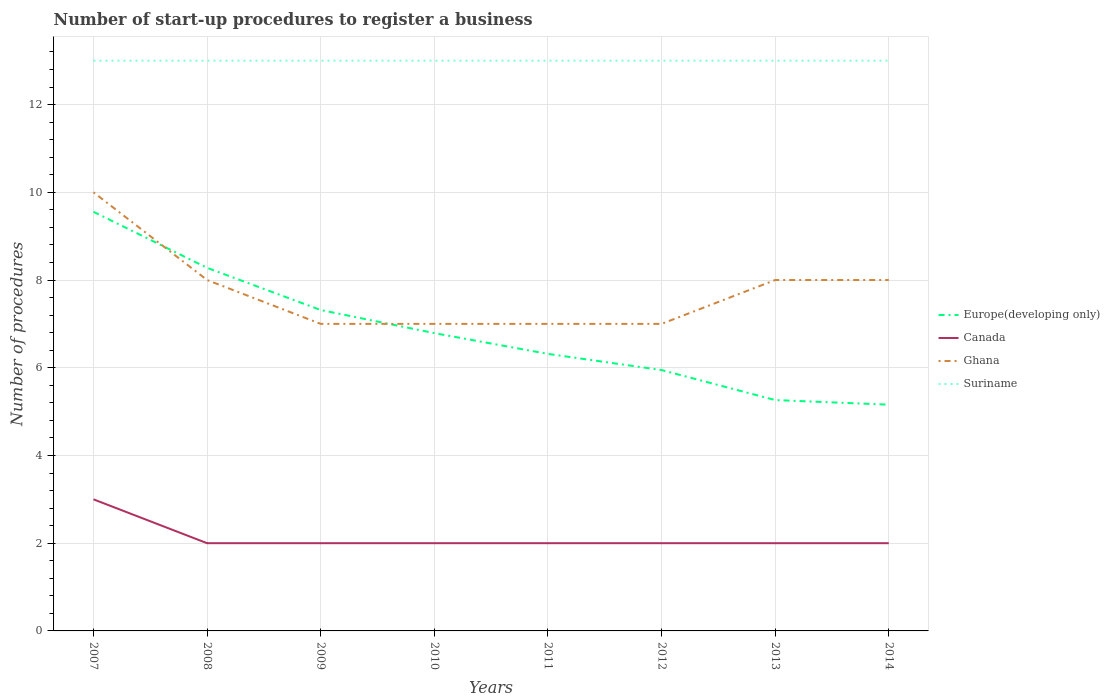How many different coloured lines are there?
Offer a terse response. 4. Is the number of lines equal to the number of legend labels?
Keep it short and to the point. Yes. Across all years, what is the maximum number of procedures required to register a business in Europe(developing only)?
Keep it short and to the point. 5.16. What is the difference between the highest and the second highest number of procedures required to register a business in Ghana?
Provide a succinct answer. 3. What is the difference between the highest and the lowest number of procedures required to register a business in Ghana?
Your response must be concise. 4. How many years are there in the graph?
Keep it short and to the point. 8. Are the values on the major ticks of Y-axis written in scientific E-notation?
Ensure brevity in your answer.  No. Does the graph contain any zero values?
Provide a short and direct response. No. Does the graph contain grids?
Offer a very short reply. Yes. Where does the legend appear in the graph?
Your response must be concise. Center right. How many legend labels are there?
Give a very brief answer. 4. How are the legend labels stacked?
Your answer should be very brief. Vertical. What is the title of the graph?
Your answer should be compact. Number of start-up procedures to register a business. Does "Kiribati" appear as one of the legend labels in the graph?
Make the answer very short. No. What is the label or title of the Y-axis?
Offer a very short reply. Number of procedures. What is the Number of procedures in Europe(developing only) in 2007?
Provide a short and direct response. 9.56. What is the Number of procedures of Canada in 2007?
Your response must be concise. 3. What is the Number of procedures of Suriname in 2007?
Provide a succinct answer. 13. What is the Number of procedures in Europe(developing only) in 2008?
Offer a terse response. 8.28. What is the Number of procedures in Canada in 2008?
Keep it short and to the point. 2. What is the Number of procedures in Suriname in 2008?
Keep it short and to the point. 13. What is the Number of procedures in Europe(developing only) in 2009?
Give a very brief answer. 7.32. What is the Number of procedures in Ghana in 2009?
Your answer should be very brief. 7. What is the Number of procedures in Suriname in 2009?
Give a very brief answer. 13. What is the Number of procedures of Europe(developing only) in 2010?
Your answer should be very brief. 6.79. What is the Number of procedures in Europe(developing only) in 2011?
Your answer should be compact. 6.32. What is the Number of procedures in Canada in 2011?
Your answer should be compact. 2. What is the Number of procedures of Europe(developing only) in 2012?
Your answer should be compact. 5.95. What is the Number of procedures of Canada in 2012?
Offer a very short reply. 2. What is the Number of procedures in Europe(developing only) in 2013?
Provide a short and direct response. 5.26. What is the Number of procedures of Suriname in 2013?
Your answer should be compact. 13. What is the Number of procedures of Europe(developing only) in 2014?
Ensure brevity in your answer.  5.16. What is the Number of procedures in Ghana in 2014?
Make the answer very short. 8. Across all years, what is the maximum Number of procedures in Europe(developing only)?
Your answer should be compact. 9.56. Across all years, what is the maximum Number of procedures in Canada?
Your answer should be compact. 3. Across all years, what is the maximum Number of procedures of Suriname?
Provide a short and direct response. 13. Across all years, what is the minimum Number of procedures of Europe(developing only)?
Offer a terse response. 5.16. Across all years, what is the minimum Number of procedures in Canada?
Keep it short and to the point. 2. Across all years, what is the minimum Number of procedures in Ghana?
Keep it short and to the point. 7. What is the total Number of procedures in Europe(developing only) in the graph?
Offer a terse response. 54.62. What is the total Number of procedures of Suriname in the graph?
Offer a terse response. 104. What is the difference between the Number of procedures of Europe(developing only) in 2007 and that in 2008?
Your answer should be very brief. 1.28. What is the difference between the Number of procedures of Canada in 2007 and that in 2008?
Ensure brevity in your answer.  1. What is the difference between the Number of procedures of Suriname in 2007 and that in 2008?
Offer a very short reply. 0. What is the difference between the Number of procedures in Europe(developing only) in 2007 and that in 2009?
Offer a terse response. 2.24. What is the difference between the Number of procedures of Canada in 2007 and that in 2009?
Your answer should be compact. 1. What is the difference between the Number of procedures in Ghana in 2007 and that in 2009?
Ensure brevity in your answer.  3. What is the difference between the Number of procedures in Suriname in 2007 and that in 2009?
Provide a succinct answer. 0. What is the difference between the Number of procedures in Europe(developing only) in 2007 and that in 2010?
Provide a succinct answer. 2.77. What is the difference between the Number of procedures in Suriname in 2007 and that in 2010?
Your answer should be compact. 0. What is the difference between the Number of procedures of Europe(developing only) in 2007 and that in 2011?
Offer a terse response. 3.24. What is the difference between the Number of procedures in Canada in 2007 and that in 2011?
Make the answer very short. 1. What is the difference between the Number of procedures in Ghana in 2007 and that in 2011?
Offer a terse response. 3. What is the difference between the Number of procedures in Europe(developing only) in 2007 and that in 2012?
Provide a succinct answer. 3.61. What is the difference between the Number of procedures of Canada in 2007 and that in 2012?
Provide a short and direct response. 1. What is the difference between the Number of procedures in Ghana in 2007 and that in 2012?
Your answer should be compact. 3. What is the difference between the Number of procedures in Europe(developing only) in 2007 and that in 2013?
Your response must be concise. 4.29. What is the difference between the Number of procedures in Europe(developing only) in 2007 and that in 2014?
Your answer should be compact. 4.4. What is the difference between the Number of procedures in Suriname in 2007 and that in 2014?
Offer a terse response. 0. What is the difference between the Number of procedures of Suriname in 2008 and that in 2009?
Ensure brevity in your answer.  0. What is the difference between the Number of procedures of Europe(developing only) in 2008 and that in 2010?
Provide a succinct answer. 1.49. What is the difference between the Number of procedures in Canada in 2008 and that in 2010?
Your answer should be compact. 0. What is the difference between the Number of procedures in Ghana in 2008 and that in 2010?
Make the answer very short. 1. What is the difference between the Number of procedures of Europe(developing only) in 2008 and that in 2011?
Your answer should be compact. 1.96. What is the difference between the Number of procedures of Ghana in 2008 and that in 2011?
Offer a terse response. 1. What is the difference between the Number of procedures in Europe(developing only) in 2008 and that in 2012?
Your response must be concise. 2.33. What is the difference between the Number of procedures in Ghana in 2008 and that in 2012?
Give a very brief answer. 1. What is the difference between the Number of procedures of Suriname in 2008 and that in 2012?
Give a very brief answer. 0. What is the difference between the Number of procedures of Europe(developing only) in 2008 and that in 2013?
Offer a very short reply. 3.01. What is the difference between the Number of procedures of Ghana in 2008 and that in 2013?
Provide a succinct answer. 0. What is the difference between the Number of procedures in Suriname in 2008 and that in 2013?
Keep it short and to the point. 0. What is the difference between the Number of procedures in Europe(developing only) in 2008 and that in 2014?
Give a very brief answer. 3.12. What is the difference between the Number of procedures in Ghana in 2008 and that in 2014?
Your answer should be very brief. 0. What is the difference between the Number of procedures in Europe(developing only) in 2009 and that in 2010?
Your response must be concise. 0.53. What is the difference between the Number of procedures in Canada in 2009 and that in 2010?
Your response must be concise. 0. What is the difference between the Number of procedures of Ghana in 2009 and that in 2010?
Provide a succinct answer. 0. What is the difference between the Number of procedures in Suriname in 2009 and that in 2010?
Your answer should be compact. 0. What is the difference between the Number of procedures in Ghana in 2009 and that in 2011?
Your answer should be very brief. 0. What is the difference between the Number of procedures of Suriname in 2009 and that in 2011?
Your answer should be compact. 0. What is the difference between the Number of procedures of Europe(developing only) in 2009 and that in 2012?
Your answer should be compact. 1.37. What is the difference between the Number of procedures in Ghana in 2009 and that in 2012?
Make the answer very short. 0. What is the difference between the Number of procedures in Suriname in 2009 and that in 2012?
Offer a very short reply. 0. What is the difference between the Number of procedures of Europe(developing only) in 2009 and that in 2013?
Your answer should be very brief. 2.05. What is the difference between the Number of procedures of Ghana in 2009 and that in 2013?
Provide a succinct answer. -1. What is the difference between the Number of procedures of Europe(developing only) in 2009 and that in 2014?
Ensure brevity in your answer.  2.16. What is the difference between the Number of procedures in Canada in 2009 and that in 2014?
Provide a short and direct response. 0. What is the difference between the Number of procedures of Ghana in 2009 and that in 2014?
Ensure brevity in your answer.  -1. What is the difference between the Number of procedures of Suriname in 2009 and that in 2014?
Offer a terse response. 0. What is the difference between the Number of procedures in Europe(developing only) in 2010 and that in 2011?
Provide a succinct answer. 0.47. What is the difference between the Number of procedures in Canada in 2010 and that in 2011?
Your response must be concise. 0. What is the difference between the Number of procedures of Ghana in 2010 and that in 2011?
Offer a terse response. 0. What is the difference between the Number of procedures of Europe(developing only) in 2010 and that in 2012?
Keep it short and to the point. 0.84. What is the difference between the Number of procedures in Suriname in 2010 and that in 2012?
Keep it short and to the point. 0. What is the difference between the Number of procedures of Europe(developing only) in 2010 and that in 2013?
Provide a succinct answer. 1.53. What is the difference between the Number of procedures in Canada in 2010 and that in 2013?
Your answer should be compact. 0. What is the difference between the Number of procedures of Suriname in 2010 and that in 2013?
Give a very brief answer. 0. What is the difference between the Number of procedures of Europe(developing only) in 2010 and that in 2014?
Your answer should be compact. 1.63. What is the difference between the Number of procedures of Suriname in 2010 and that in 2014?
Offer a terse response. 0. What is the difference between the Number of procedures of Europe(developing only) in 2011 and that in 2012?
Provide a short and direct response. 0.37. What is the difference between the Number of procedures of Suriname in 2011 and that in 2012?
Make the answer very short. 0. What is the difference between the Number of procedures in Europe(developing only) in 2011 and that in 2013?
Provide a succinct answer. 1.05. What is the difference between the Number of procedures in Ghana in 2011 and that in 2013?
Give a very brief answer. -1. What is the difference between the Number of procedures in Europe(developing only) in 2011 and that in 2014?
Ensure brevity in your answer.  1.16. What is the difference between the Number of procedures of Ghana in 2011 and that in 2014?
Provide a succinct answer. -1. What is the difference between the Number of procedures in Suriname in 2011 and that in 2014?
Provide a short and direct response. 0. What is the difference between the Number of procedures of Europe(developing only) in 2012 and that in 2013?
Your answer should be compact. 0.68. What is the difference between the Number of procedures of Ghana in 2012 and that in 2013?
Provide a succinct answer. -1. What is the difference between the Number of procedures in Suriname in 2012 and that in 2013?
Provide a succinct answer. 0. What is the difference between the Number of procedures in Europe(developing only) in 2012 and that in 2014?
Your response must be concise. 0.79. What is the difference between the Number of procedures in Canada in 2012 and that in 2014?
Keep it short and to the point. 0. What is the difference between the Number of procedures of Ghana in 2012 and that in 2014?
Offer a terse response. -1. What is the difference between the Number of procedures of Europe(developing only) in 2013 and that in 2014?
Give a very brief answer. 0.11. What is the difference between the Number of procedures in Canada in 2013 and that in 2014?
Give a very brief answer. 0. What is the difference between the Number of procedures in Ghana in 2013 and that in 2014?
Keep it short and to the point. 0. What is the difference between the Number of procedures in Europe(developing only) in 2007 and the Number of procedures in Canada in 2008?
Ensure brevity in your answer.  7.56. What is the difference between the Number of procedures in Europe(developing only) in 2007 and the Number of procedures in Ghana in 2008?
Keep it short and to the point. 1.56. What is the difference between the Number of procedures of Europe(developing only) in 2007 and the Number of procedures of Suriname in 2008?
Your answer should be very brief. -3.44. What is the difference between the Number of procedures of Canada in 2007 and the Number of procedures of Ghana in 2008?
Offer a terse response. -5. What is the difference between the Number of procedures of Europe(developing only) in 2007 and the Number of procedures of Canada in 2009?
Offer a very short reply. 7.56. What is the difference between the Number of procedures in Europe(developing only) in 2007 and the Number of procedures in Ghana in 2009?
Make the answer very short. 2.56. What is the difference between the Number of procedures in Europe(developing only) in 2007 and the Number of procedures in Suriname in 2009?
Provide a short and direct response. -3.44. What is the difference between the Number of procedures in Canada in 2007 and the Number of procedures in Ghana in 2009?
Ensure brevity in your answer.  -4. What is the difference between the Number of procedures of Ghana in 2007 and the Number of procedures of Suriname in 2009?
Offer a terse response. -3. What is the difference between the Number of procedures of Europe(developing only) in 2007 and the Number of procedures of Canada in 2010?
Offer a terse response. 7.56. What is the difference between the Number of procedures in Europe(developing only) in 2007 and the Number of procedures in Ghana in 2010?
Offer a very short reply. 2.56. What is the difference between the Number of procedures in Europe(developing only) in 2007 and the Number of procedures in Suriname in 2010?
Offer a terse response. -3.44. What is the difference between the Number of procedures of Canada in 2007 and the Number of procedures of Ghana in 2010?
Offer a very short reply. -4. What is the difference between the Number of procedures of Ghana in 2007 and the Number of procedures of Suriname in 2010?
Make the answer very short. -3. What is the difference between the Number of procedures in Europe(developing only) in 2007 and the Number of procedures in Canada in 2011?
Ensure brevity in your answer.  7.56. What is the difference between the Number of procedures in Europe(developing only) in 2007 and the Number of procedures in Ghana in 2011?
Your response must be concise. 2.56. What is the difference between the Number of procedures in Europe(developing only) in 2007 and the Number of procedures in Suriname in 2011?
Give a very brief answer. -3.44. What is the difference between the Number of procedures in Europe(developing only) in 2007 and the Number of procedures in Canada in 2012?
Your answer should be very brief. 7.56. What is the difference between the Number of procedures in Europe(developing only) in 2007 and the Number of procedures in Ghana in 2012?
Your answer should be compact. 2.56. What is the difference between the Number of procedures in Europe(developing only) in 2007 and the Number of procedures in Suriname in 2012?
Your response must be concise. -3.44. What is the difference between the Number of procedures of Canada in 2007 and the Number of procedures of Suriname in 2012?
Offer a very short reply. -10. What is the difference between the Number of procedures in Ghana in 2007 and the Number of procedures in Suriname in 2012?
Your answer should be compact. -3. What is the difference between the Number of procedures in Europe(developing only) in 2007 and the Number of procedures in Canada in 2013?
Your response must be concise. 7.56. What is the difference between the Number of procedures in Europe(developing only) in 2007 and the Number of procedures in Ghana in 2013?
Provide a short and direct response. 1.56. What is the difference between the Number of procedures of Europe(developing only) in 2007 and the Number of procedures of Suriname in 2013?
Make the answer very short. -3.44. What is the difference between the Number of procedures of Ghana in 2007 and the Number of procedures of Suriname in 2013?
Offer a terse response. -3. What is the difference between the Number of procedures in Europe(developing only) in 2007 and the Number of procedures in Canada in 2014?
Keep it short and to the point. 7.56. What is the difference between the Number of procedures of Europe(developing only) in 2007 and the Number of procedures of Ghana in 2014?
Offer a very short reply. 1.56. What is the difference between the Number of procedures in Europe(developing only) in 2007 and the Number of procedures in Suriname in 2014?
Provide a succinct answer. -3.44. What is the difference between the Number of procedures of Canada in 2007 and the Number of procedures of Suriname in 2014?
Provide a succinct answer. -10. What is the difference between the Number of procedures in Ghana in 2007 and the Number of procedures in Suriname in 2014?
Your answer should be compact. -3. What is the difference between the Number of procedures of Europe(developing only) in 2008 and the Number of procedures of Canada in 2009?
Provide a succinct answer. 6.28. What is the difference between the Number of procedures in Europe(developing only) in 2008 and the Number of procedures in Ghana in 2009?
Keep it short and to the point. 1.28. What is the difference between the Number of procedures of Europe(developing only) in 2008 and the Number of procedures of Suriname in 2009?
Offer a terse response. -4.72. What is the difference between the Number of procedures of Ghana in 2008 and the Number of procedures of Suriname in 2009?
Keep it short and to the point. -5. What is the difference between the Number of procedures in Europe(developing only) in 2008 and the Number of procedures in Canada in 2010?
Provide a succinct answer. 6.28. What is the difference between the Number of procedures of Europe(developing only) in 2008 and the Number of procedures of Ghana in 2010?
Provide a short and direct response. 1.28. What is the difference between the Number of procedures in Europe(developing only) in 2008 and the Number of procedures in Suriname in 2010?
Ensure brevity in your answer.  -4.72. What is the difference between the Number of procedures in Europe(developing only) in 2008 and the Number of procedures in Canada in 2011?
Your response must be concise. 6.28. What is the difference between the Number of procedures of Europe(developing only) in 2008 and the Number of procedures of Ghana in 2011?
Give a very brief answer. 1.28. What is the difference between the Number of procedures of Europe(developing only) in 2008 and the Number of procedures of Suriname in 2011?
Keep it short and to the point. -4.72. What is the difference between the Number of procedures in Europe(developing only) in 2008 and the Number of procedures in Canada in 2012?
Ensure brevity in your answer.  6.28. What is the difference between the Number of procedures of Europe(developing only) in 2008 and the Number of procedures of Ghana in 2012?
Ensure brevity in your answer.  1.28. What is the difference between the Number of procedures of Europe(developing only) in 2008 and the Number of procedures of Suriname in 2012?
Ensure brevity in your answer.  -4.72. What is the difference between the Number of procedures of Canada in 2008 and the Number of procedures of Ghana in 2012?
Your answer should be compact. -5. What is the difference between the Number of procedures of Europe(developing only) in 2008 and the Number of procedures of Canada in 2013?
Offer a very short reply. 6.28. What is the difference between the Number of procedures in Europe(developing only) in 2008 and the Number of procedures in Ghana in 2013?
Offer a very short reply. 0.28. What is the difference between the Number of procedures of Europe(developing only) in 2008 and the Number of procedures of Suriname in 2013?
Ensure brevity in your answer.  -4.72. What is the difference between the Number of procedures of Canada in 2008 and the Number of procedures of Suriname in 2013?
Ensure brevity in your answer.  -11. What is the difference between the Number of procedures in Ghana in 2008 and the Number of procedures in Suriname in 2013?
Your answer should be very brief. -5. What is the difference between the Number of procedures in Europe(developing only) in 2008 and the Number of procedures in Canada in 2014?
Your response must be concise. 6.28. What is the difference between the Number of procedures in Europe(developing only) in 2008 and the Number of procedures in Ghana in 2014?
Provide a short and direct response. 0.28. What is the difference between the Number of procedures in Europe(developing only) in 2008 and the Number of procedures in Suriname in 2014?
Keep it short and to the point. -4.72. What is the difference between the Number of procedures in Europe(developing only) in 2009 and the Number of procedures in Canada in 2010?
Offer a very short reply. 5.32. What is the difference between the Number of procedures in Europe(developing only) in 2009 and the Number of procedures in Ghana in 2010?
Provide a short and direct response. 0.32. What is the difference between the Number of procedures of Europe(developing only) in 2009 and the Number of procedures of Suriname in 2010?
Give a very brief answer. -5.68. What is the difference between the Number of procedures of Europe(developing only) in 2009 and the Number of procedures of Canada in 2011?
Keep it short and to the point. 5.32. What is the difference between the Number of procedures of Europe(developing only) in 2009 and the Number of procedures of Ghana in 2011?
Offer a terse response. 0.32. What is the difference between the Number of procedures in Europe(developing only) in 2009 and the Number of procedures in Suriname in 2011?
Offer a very short reply. -5.68. What is the difference between the Number of procedures of Ghana in 2009 and the Number of procedures of Suriname in 2011?
Your answer should be very brief. -6. What is the difference between the Number of procedures of Europe(developing only) in 2009 and the Number of procedures of Canada in 2012?
Your answer should be compact. 5.32. What is the difference between the Number of procedures of Europe(developing only) in 2009 and the Number of procedures of Ghana in 2012?
Offer a terse response. 0.32. What is the difference between the Number of procedures in Europe(developing only) in 2009 and the Number of procedures in Suriname in 2012?
Make the answer very short. -5.68. What is the difference between the Number of procedures in Ghana in 2009 and the Number of procedures in Suriname in 2012?
Offer a terse response. -6. What is the difference between the Number of procedures in Europe(developing only) in 2009 and the Number of procedures in Canada in 2013?
Offer a terse response. 5.32. What is the difference between the Number of procedures in Europe(developing only) in 2009 and the Number of procedures in Ghana in 2013?
Make the answer very short. -0.68. What is the difference between the Number of procedures of Europe(developing only) in 2009 and the Number of procedures of Suriname in 2013?
Ensure brevity in your answer.  -5.68. What is the difference between the Number of procedures of Canada in 2009 and the Number of procedures of Suriname in 2013?
Provide a short and direct response. -11. What is the difference between the Number of procedures of Ghana in 2009 and the Number of procedures of Suriname in 2013?
Your response must be concise. -6. What is the difference between the Number of procedures in Europe(developing only) in 2009 and the Number of procedures in Canada in 2014?
Provide a succinct answer. 5.32. What is the difference between the Number of procedures of Europe(developing only) in 2009 and the Number of procedures of Ghana in 2014?
Your response must be concise. -0.68. What is the difference between the Number of procedures of Europe(developing only) in 2009 and the Number of procedures of Suriname in 2014?
Provide a succinct answer. -5.68. What is the difference between the Number of procedures in Canada in 2009 and the Number of procedures in Ghana in 2014?
Offer a very short reply. -6. What is the difference between the Number of procedures of Ghana in 2009 and the Number of procedures of Suriname in 2014?
Make the answer very short. -6. What is the difference between the Number of procedures in Europe(developing only) in 2010 and the Number of procedures in Canada in 2011?
Offer a terse response. 4.79. What is the difference between the Number of procedures of Europe(developing only) in 2010 and the Number of procedures of Ghana in 2011?
Offer a terse response. -0.21. What is the difference between the Number of procedures in Europe(developing only) in 2010 and the Number of procedures in Suriname in 2011?
Keep it short and to the point. -6.21. What is the difference between the Number of procedures of Canada in 2010 and the Number of procedures of Ghana in 2011?
Make the answer very short. -5. What is the difference between the Number of procedures in Ghana in 2010 and the Number of procedures in Suriname in 2011?
Your answer should be very brief. -6. What is the difference between the Number of procedures in Europe(developing only) in 2010 and the Number of procedures in Canada in 2012?
Provide a succinct answer. 4.79. What is the difference between the Number of procedures in Europe(developing only) in 2010 and the Number of procedures in Ghana in 2012?
Make the answer very short. -0.21. What is the difference between the Number of procedures in Europe(developing only) in 2010 and the Number of procedures in Suriname in 2012?
Your answer should be compact. -6.21. What is the difference between the Number of procedures of Canada in 2010 and the Number of procedures of Ghana in 2012?
Offer a very short reply. -5. What is the difference between the Number of procedures in Canada in 2010 and the Number of procedures in Suriname in 2012?
Ensure brevity in your answer.  -11. What is the difference between the Number of procedures of Europe(developing only) in 2010 and the Number of procedures of Canada in 2013?
Give a very brief answer. 4.79. What is the difference between the Number of procedures of Europe(developing only) in 2010 and the Number of procedures of Ghana in 2013?
Your response must be concise. -1.21. What is the difference between the Number of procedures of Europe(developing only) in 2010 and the Number of procedures of Suriname in 2013?
Make the answer very short. -6.21. What is the difference between the Number of procedures in Canada in 2010 and the Number of procedures in Ghana in 2013?
Make the answer very short. -6. What is the difference between the Number of procedures in Canada in 2010 and the Number of procedures in Suriname in 2013?
Give a very brief answer. -11. What is the difference between the Number of procedures in Ghana in 2010 and the Number of procedures in Suriname in 2013?
Ensure brevity in your answer.  -6. What is the difference between the Number of procedures of Europe(developing only) in 2010 and the Number of procedures of Canada in 2014?
Ensure brevity in your answer.  4.79. What is the difference between the Number of procedures of Europe(developing only) in 2010 and the Number of procedures of Ghana in 2014?
Your response must be concise. -1.21. What is the difference between the Number of procedures in Europe(developing only) in 2010 and the Number of procedures in Suriname in 2014?
Your answer should be compact. -6.21. What is the difference between the Number of procedures in Ghana in 2010 and the Number of procedures in Suriname in 2014?
Your answer should be very brief. -6. What is the difference between the Number of procedures in Europe(developing only) in 2011 and the Number of procedures in Canada in 2012?
Provide a short and direct response. 4.32. What is the difference between the Number of procedures in Europe(developing only) in 2011 and the Number of procedures in Ghana in 2012?
Give a very brief answer. -0.68. What is the difference between the Number of procedures of Europe(developing only) in 2011 and the Number of procedures of Suriname in 2012?
Provide a succinct answer. -6.68. What is the difference between the Number of procedures in Canada in 2011 and the Number of procedures in Suriname in 2012?
Your answer should be very brief. -11. What is the difference between the Number of procedures in Ghana in 2011 and the Number of procedures in Suriname in 2012?
Provide a short and direct response. -6. What is the difference between the Number of procedures in Europe(developing only) in 2011 and the Number of procedures in Canada in 2013?
Offer a terse response. 4.32. What is the difference between the Number of procedures in Europe(developing only) in 2011 and the Number of procedures in Ghana in 2013?
Provide a succinct answer. -1.68. What is the difference between the Number of procedures in Europe(developing only) in 2011 and the Number of procedures in Suriname in 2013?
Offer a terse response. -6.68. What is the difference between the Number of procedures in Canada in 2011 and the Number of procedures in Ghana in 2013?
Make the answer very short. -6. What is the difference between the Number of procedures in Canada in 2011 and the Number of procedures in Suriname in 2013?
Provide a succinct answer. -11. What is the difference between the Number of procedures of Europe(developing only) in 2011 and the Number of procedures of Canada in 2014?
Provide a succinct answer. 4.32. What is the difference between the Number of procedures of Europe(developing only) in 2011 and the Number of procedures of Ghana in 2014?
Provide a succinct answer. -1.68. What is the difference between the Number of procedures of Europe(developing only) in 2011 and the Number of procedures of Suriname in 2014?
Your response must be concise. -6.68. What is the difference between the Number of procedures of Europe(developing only) in 2012 and the Number of procedures of Canada in 2013?
Ensure brevity in your answer.  3.95. What is the difference between the Number of procedures in Europe(developing only) in 2012 and the Number of procedures in Ghana in 2013?
Keep it short and to the point. -2.05. What is the difference between the Number of procedures of Europe(developing only) in 2012 and the Number of procedures of Suriname in 2013?
Make the answer very short. -7.05. What is the difference between the Number of procedures of Canada in 2012 and the Number of procedures of Ghana in 2013?
Your response must be concise. -6. What is the difference between the Number of procedures in Ghana in 2012 and the Number of procedures in Suriname in 2013?
Keep it short and to the point. -6. What is the difference between the Number of procedures in Europe(developing only) in 2012 and the Number of procedures in Canada in 2014?
Provide a succinct answer. 3.95. What is the difference between the Number of procedures of Europe(developing only) in 2012 and the Number of procedures of Ghana in 2014?
Offer a terse response. -2.05. What is the difference between the Number of procedures in Europe(developing only) in 2012 and the Number of procedures in Suriname in 2014?
Ensure brevity in your answer.  -7.05. What is the difference between the Number of procedures of Canada in 2012 and the Number of procedures of Suriname in 2014?
Ensure brevity in your answer.  -11. What is the difference between the Number of procedures in Ghana in 2012 and the Number of procedures in Suriname in 2014?
Your answer should be very brief. -6. What is the difference between the Number of procedures of Europe(developing only) in 2013 and the Number of procedures of Canada in 2014?
Your response must be concise. 3.26. What is the difference between the Number of procedures of Europe(developing only) in 2013 and the Number of procedures of Ghana in 2014?
Ensure brevity in your answer.  -2.74. What is the difference between the Number of procedures in Europe(developing only) in 2013 and the Number of procedures in Suriname in 2014?
Your response must be concise. -7.74. What is the difference between the Number of procedures in Canada in 2013 and the Number of procedures in Ghana in 2014?
Offer a very short reply. -6. What is the difference between the Number of procedures of Canada in 2013 and the Number of procedures of Suriname in 2014?
Your answer should be very brief. -11. What is the average Number of procedures of Europe(developing only) per year?
Your answer should be very brief. 6.83. What is the average Number of procedures in Canada per year?
Provide a succinct answer. 2.12. What is the average Number of procedures in Ghana per year?
Make the answer very short. 7.75. What is the average Number of procedures in Suriname per year?
Offer a very short reply. 13. In the year 2007, what is the difference between the Number of procedures of Europe(developing only) and Number of procedures of Canada?
Your answer should be compact. 6.56. In the year 2007, what is the difference between the Number of procedures of Europe(developing only) and Number of procedures of Ghana?
Offer a terse response. -0.44. In the year 2007, what is the difference between the Number of procedures in Europe(developing only) and Number of procedures in Suriname?
Offer a very short reply. -3.44. In the year 2008, what is the difference between the Number of procedures of Europe(developing only) and Number of procedures of Canada?
Your response must be concise. 6.28. In the year 2008, what is the difference between the Number of procedures of Europe(developing only) and Number of procedures of Ghana?
Your answer should be very brief. 0.28. In the year 2008, what is the difference between the Number of procedures in Europe(developing only) and Number of procedures in Suriname?
Offer a very short reply. -4.72. In the year 2008, what is the difference between the Number of procedures of Canada and Number of procedures of Ghana?
Ensure brevity in your answer.  -6. In the year 2008, what is the difference between the Number of procedures in Ghana and Number of procedures in Suriname?
Your answer should be compact. -5. In the year 2009, what is the difference between the Number of procedures in Europe(developing only) and Number of procedures in Canada?
Keep it short and to the point. 5.32. In the year 2009, what is the difference between the Number of procedures of Europe(developing only) and Number of procedures of Ghana?
Keep it short and to the point. 0.32. In the year 2009, what is the difference between the Number of procedures in Europe(developing only) and Number of procedures in Suriname?
Your answer should be compact. -5.68. In the year 2009, what is the difference between the Number of procedures of Canada and Number of procedures of Ghana?
Provide a succinct answer. -5. In the year 2009, what is the difference between the Number of procedures of Canada and Number of procedures of Suriname?
Your answer should be compact. -11. In the year 2010, what is the difference between the Number of procedures of Europe(developing only) and Number of procedures of Canada?
Your response must be concise. 4.79. In the year 2010, what is the difference between the Number of procedures in Europe(developing only) and Number of procedures in Ghana?
Make the answer very short. -0.21. In the year 2010, what is the difference between the Number of procedures of Europe(developing only) and Number of procedures of Suriname?
Offer a very short reply. -6.21. In the year 2010, what is the difference between the Number of procedures of Canada and Number of procedures of Suriname?
Make the answer very short. -11. In the year 2010, what is the difference between the Number of procedures of Ghana and Number of procedures of Suriname?
Your answer should be very brief. -6. In the year 2011, what is the difference between the Number of procedures in Europe(developing only) and Number of procedures in Canada?
Ensure brevity in your answer.  4.32. In the year 2011, what is the difference between the Number of procedures in Europe(developing only) and Number of procedures in Ghana?
Ensure brevity in your answer.  -0.68. In the year 2011, what is the difference between the Number of procedures of Europe(developing only) and Number of procedures of Suriname?
Make the answer very short. -6.68. In the year 2011, what is the difference between the Number of procedures of Canada and Number of procedures of Ghana?
Offer a terse response. -5. In the year 2012, what is the difference between the Number of procedures in Europe(developing only) and Number of procedures in Canada?
Ensure brevity in your answer.  3.95. In the year 2012, what is the difference between the Number of procedures in Europe(developing only) and Number of procedures in Ghana?
Provide a short and direct response. -1.05. In the year 2012, what is the difference between the Number of procedures of Europe(developing only) and Number of procedures of Suriname?
Make the answer very short. -7.05. In the year 2012, what is the difference between the Number of procedures of Canada and Number of procedures of Ghana?
Your response must be concise. -5. In the year 2012, what is the difference between the Number of procedures in Canada and Number of procedures in Suriname?
Give a very brief answer. -11. In the year 2012, what is the difference between the Number of procedures of Ghana and Number of procedures of Suriname?
Provide a succinct answer. -6. In the year 2013, what is the difference between the Number of procedures of Europe(developing only) and Number of procedures of Canada?
Give a very brief answer. 3.26. In the year 2013, what is the difference between the Number of procedures in Europe(developing only) and Number of procedures in Ghana?
Offer a terse response. -2.74. In the year 2013, what is the difference between the Number of procedures of Europe(developing only) and Number of procedures of Suriname?
Your answer should be very brief. -7.74. In the year 2013, what is the difference between the Number of procedures in Canada and Number of procedures in Ghana?
Provide a short and direct response. -6. In the year 2013, what is the difference between the Number of procedures of Canada and Number of procedures of Suriname?
Keep it short and to the point. -11. In the year 2014, what is the difference between the Number of procedures of Europe(developing only) and Number of procedures of Canada?
Offer a terse response. 3.16. In the year 2014, what is the difference between the Number of procedures in Europe(developing only) and Number of procedures in Ghana?
Your answer should be very brief. -2.84. In the year 2014, what is the difference between the Number of procedures in Europe(developing only) and Number of procedures in Suriname?
Your response must be concise. -7.84. In the year 2014, what is the difference between the Number of procedures in Canada and Number of procedures in Ghana?
Ensure brevity in your answer.  -6. In the year 2014, what is the difference between the Number of procedures in Canada and Number of procedures in Suriname?
Give a very brief answer. -11. In the year 2014, what is the difference between the Number of procedures of Ghana and Number of procedures of Suriname?
Offer a very short reply. -5. What is the ratio of the Number of procedures of Europe(developing only) in 2007 to that in 2008?
Provide a succinct answer. 1.15. What is the ratio of the Number of procedures in Canada in 2007 to that in 2008?
Give a very brief answer. 1.5. What is the ratio of the Number of procedures of Europe(developing only) in 2007 to that in 2009?
Give a very brief answer. 1.31. What is the ratio of the Number of procedures in Canada in 2007 to that in 2009?
Offer a terse response. 1.5. What is the ratio of the Number of procedures of Ghana in 2007 to that in 2009?
Offer a very short reply. 1.43. What is the ratio of the Number of procedures in Europe(developing only) in 2007 to that in 2010?
Your response must be concise. 1.41. What is the ratio of the Number of procedures of Canada in 2007 to that in 2010?
Provide a succinct answer. 1.5. What is the ratio of the Number of procedures of Ghana in 2007 to that in 2010?
Make the answer very short. 1.43. What is the ratio of the Number of procedures of Suriname in 2007 to that in 2010?
Give a very brief answer. 1. What is the ratio of the Number of procedures of Europe(developing only) in 2007 to that in 2011?
Provide a succinct answer. 1.51. What is the ratio of the Number of procedures in Canada in 2007 to that in 2011?
Offer a terse response. 1.5. What is the ratio of the Number of procedures in Ghana in 2007 to that in 2011?
Offer a terse response. 1.43. What is the ratio of the Number of procedures in Suriname in 2007 to that in 2011?
Offer a very short reply. 1. What is the ratio of the Number of procedures of Europe(developing only) in 2007 to that in 2012?
Give a very brief answer. 1.61. What is the ratio of the Number of procedures of Ghana in 2007 to that in 2012?
Your response must be concise. 1.43. What is the ratio of the Number of procedures of Europe(developing only) in 2007 to that in 2013?
Your answer should be very brief. 1.82. What is the ratio of the Number of procedures in Canada in 2007 to that in 2013?
Offer a terse response. 1.5. What is the ratio of the Number of procedures of Ghana in 2007 to that in 2013?
Give a very brief answer. 1.25. What is the ratio of the Number of procedures in Suriname in 2007 to that in 2013?
Offer a terse response. 1. What is the ratio of the Number of procedures of Europe(developing only) in 2007 to that in 2014?
Give a very brief answer. 1.85. What is the ratio of the Number of procedures of Canada in 2007 to that in 2014?
Keep it short and to the point. 1.5. What is the ratio of the Number of procedures in Ghana in 2007 to that in 2014?
Offer a terse response. 1.25. What is the ratio of the Number of procedures of Suriname in 2007 to that in 2014?
Make the answer very short. 1. What is the ratio of the Number of procedures of Europe(developing only) in 2008 to that in 2009?
Provide a succinct answer. 1.13. What is the ratio of the Number of procedures of Ghana in 2008 to that in 2009?
Your response must be concise. 1.14. What is the ratio of the Number of procedures in Europe(developing only) in 2008 to that in 2010?
Your answer should be very brief. 1.22. What is the ratio of the Number of procedures of Suriname in 2008 to that in 2010?
Your answer should be very brief. 1. What is the ratio of the Number of procedures in Europe(developing only) in 2008 to that in 2011?
Provide a succinct answer. 1.31. What is the ratio of the Number of procedures of Suriname in 2008 to that in 2011?
Make the answer very short. 1. What is the ratio of the Number of procedures in Europe(developing only) in 2008 to that in 2012?
Provide a short and direct response. 1.39. What is the ratio of the Number of procedures in Canada in 2008 to that in 2012?
Your answer should be very brief. 1. What is the ratio of the Number of procedures of Ghana in 2008 to that in 2012?
Your answer should be compact. 1.14. What is the ratio of the Number of procedures in Europe(developing only) in 2008 to that in 2013?
Ensure brevity in your answer.  1.57. What is the ratio of the Number of procedures of Suriname in 2008 to that in 2013?
Provide a short and direct response. 1. What is the ratio of the Number of procedures of Europe(developing only) in 2008 to that in 2014?
Provide a short and direct response. 1.6. What is the ratio of the Number of procedures of Canada in 2008 to that in 2014?
Ensure brevity in your answer.  1. What is the ratio of the Number of procedures in Suriname in 2008 to that in 2014?
Offer a very short reply. 1. What is the ratio of the Number of procedures in Europe(developing only) in 2009 to that in 2010?
Keep it short and to the point. 1.08. What is the ratio of the Number of procedures of Canada in 2009 to that in 2010?
Give a very brief answer. 1. What is the ratio of the Number of procedures of Ghana in 2009 to that in 2010?
Your answer should be compact. 1. What is the ratio of the Number of procedures of Europe(developing only) in 2009 to that in 2011?
Provide a succinct answer. 1.16. What is the ratio of the Number of procedures in Canada in 2009 to that in 2011?
Make the answer very short. 1. What is the ratio of the Number of procedures of Suriname in 2009 to that in 2011?
Your answer should be compact. 1. What is the ratio of the Number of procedures of Europe(developing only) in 2009 to that in 2012?
Provide a succinct answer. 1.23. What is the ratio of the Number of procedures of Canada in 2009 to that in 2012?
Provide a succinct answer. 1. What is the ratio of the Number of procedures of Ghana in 2009 to that in 2012?
Provide a succinct answer. 1. What is the ratio of the Number of procedures of Suriname in 2009 to that in 2012?
Make the answer very short. 1. What is the ratio of the Number of procedures of Europe(developing only) in 2009 to that in 2013?
Give a very brief answer. 1.39. What is the ratio of the Number of procedures of Canada in 2009 to that in 2013?
Your response must be concise. 1. What is the ratio of the Number of procedures of Europe(developing only) in 2009 to that in 2014?
Offer a very short reply. 1.42. What is the ratio of the Number of procedures of Canada in 2009 to that in 2014?
Provide a succinct answer. 1. What is the ratio of the Number of procedures of Ghana in 2009 to that in 2014?
Offer a very short reply. 0.88. What is the ratio of the Number of procedures of Suriname in 2009 to that in 2014?
Offer a very short reply. 1. What is the ratio of the Number of procedures in Europe(developing only) in 2010 to that in 2011?
Give a very brief answer. 1.07. What is the ratio of the Number of procedures in Suriname in 2010 to that in 2011?
Offer a very short reply. 1. What is the ratio of the Number of procedures of Europe(developing only) in 2010 to that in 2012?
Your answer should be very brief. 1.14. What is the ratio of the Number of procedures of Ghana in 2010 to that in 2012?
Your response must be concise. 1. What is the ratio of the Number of procedures of Suriname in 2010 to that in 2012?
Give a very brief answer. 1. What is the ratio of the Number of procedures of Europe(developing only) in 2010 to that in 2013?
Provide a succinct answer. 1.29. What is the ratio of the Number of procedures in Canada in 2010 to that in 2013?
Offer a very short reply. 1. What is the ratio of the Number of procedures in Ghana in 2010 to that in 2013?
Your answer should be compact. 0.88. What is the ratio of the Number of procedures in Suriname in 2010 to that in 2013?
Provide a short and direct response. 1. What is the ratio of the Number of procedures in Europe(developing only) in 2010 to that in 2014?
Make the answer very short. 1.32. What is the ratio of the Number of procedures of Suriname in 2010 to that in 2014?
Offer a terse response. 1. What is the ratio of the Number of procedures of Europe(developing only) in 2011 to that in 2012?
Your answer should be very brief. 1.06. What is the ratio of the Number of procedures of Canada in 2011 to that in 2013?
Provide a short and direct response. 1. What is the ratio of the Number of procedures of Suriname in 2011 to that in 2013?
Keep it short and to the point. 1. What is the ratio of the Number of procedures in Europe(developing only) in 2011 to that in 2014?
Ensure brevity in your answer.  1.22. What is the ratio of the Number of procedures in Europe(developing only) in 2012 to that in 2013?
Make the answer very short. 1.13. What is the ratio of the Number of procedures in Suriname in 2012 to that in 2013?
Keep it short and to the point. 1. What is the ratio of the Number of procedures in Europe(developing only) in 2012 to that in 2014?
Provide a short and direct response. 1.15. What is the ratio of the Number of procedures of Europe(developing only) in 2013 to that in 2014?
Offer a very short reply. 1.02. What is the ratio of the Number of procedures of Ghana in 2013 to that in 2014?
Offer a terse response. 1. What is the ratio of the Number of procedures of Suriname in 2013 to that in 2014?
Offer a very short reply. 1. What is the difference between the highest and the second highest Number of procedures in Europe(developing only)?
Keep it short and to the point. 1.28. What is the difference between the highest and the lowest Number of procedures in Europe(developing only)?
Your answer should be very brief. 4.4. What is the difference between the highest and the lowest Number of procedures of Canada?
Give a very brief answer. 1. What is the difference between the highest and the lowest Number of procedures of Ghana?
Your answer should be very brief. 3. What is the difference between the highest and the lowest Number of procedures of Suriname?
Keep it short and to the point. 0. 